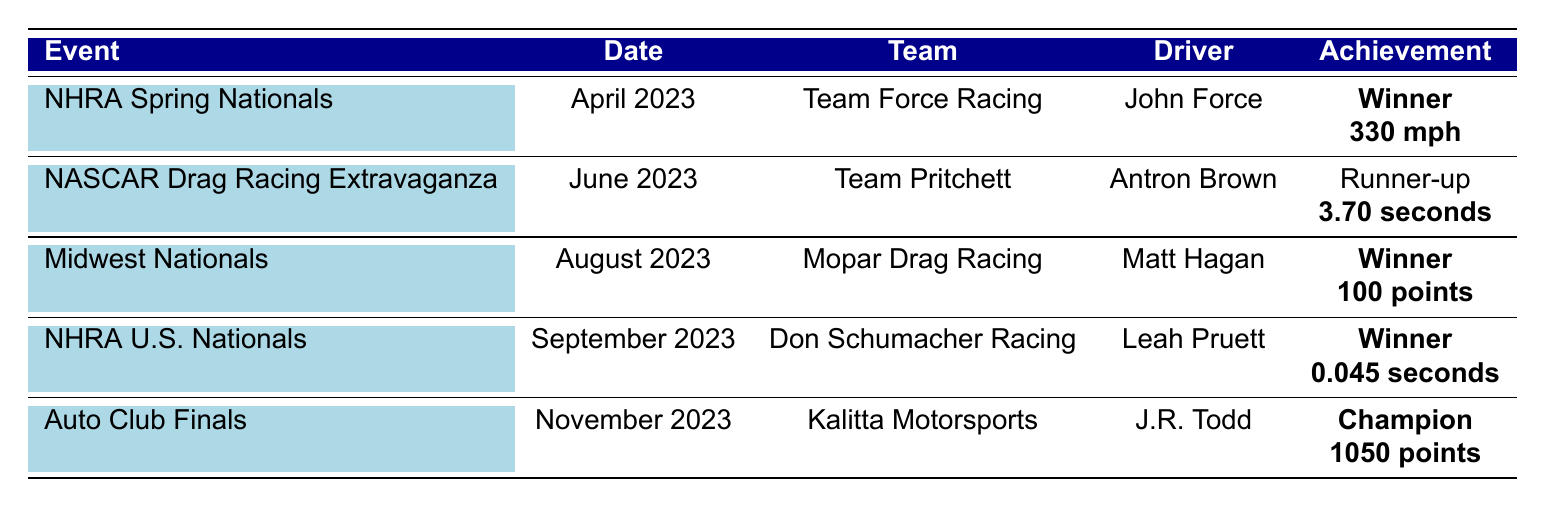What team won the NHRA Spring Nationals? The table shows that Team Force Racing won the NHRA Spring Nationals.
Answer: Team Force Racing What was the elapsed time for the runner-up at the NASCAR Drag Racing Extravaganza? The table indicates that the elapsed time for Antron Brown, the runner-up, was 3.70 seconds.
Answer: 3.70 seconds Who was the driver for Mopar Drag Racing at the Midwest Nationals? According to the table, the driver for Mopar Drag Racing at the Midwest Nationals was Matt Hagan.
Answer: Matt Hagan How many points did Don Schumacher Racing accumulate at the NHRA U.S. Nationals? The table lists that Don Schumacher Racing, driven by Leah Pruett, won the NHRA U.S. Nationals but does not specify points, so we cannot determine the points from this event alone.
Answer: Not specified Which event did Kalitta Motorsports win to become the Champion? The table states that Kalitta Motorsports won the Auto Club Finals, which designated them as the Champion.
Answer: Auto Club Finals How many events did Team Force Racing win in 2023 based on this table? Team Force Racing won one event, the NHRA Spring Nationals, as shown in the table.
Answer: 1 What is the average speed of the winning team from the NHRA Spring Nationals and the elapsed time of the runner-up from the NASCAR Drag Racing Extravaganza? From the table, the speed of the winner (Team Force Racing) is 330 mph, and the elapsed time of the runner-up (Antron Brown) is 3.70 seconds. The two values cannot be averaged meaningfully as they represent different metrics.
Answer: Cannot be averaged Did any team collect 1050 championship points, and if so, which team was it? The table shows that Kalitta Motorsports collected 1050 championship points, confirming that yes, this team had that total.
Answer: Yes, Kalitta Motorsports Who had the best reaction time in 2023 according to this data? Looking at the table, Leah Pruett from Don Schumacher Racing had a reaction time of 0.045 seconds, which is the best time listed.
Answer: Leah Pruett Which event had the driver with the highest recorded speed? The NHRA Spring Nationals is noted in the table to have the highest recorded speed of 330 mph by John Force.
Answer: NHRA Spring Nationals Which event was held in November 2023? The table indicates that the Auto Club Finals were held in November 2023.
Answer: Auto Club Finals 